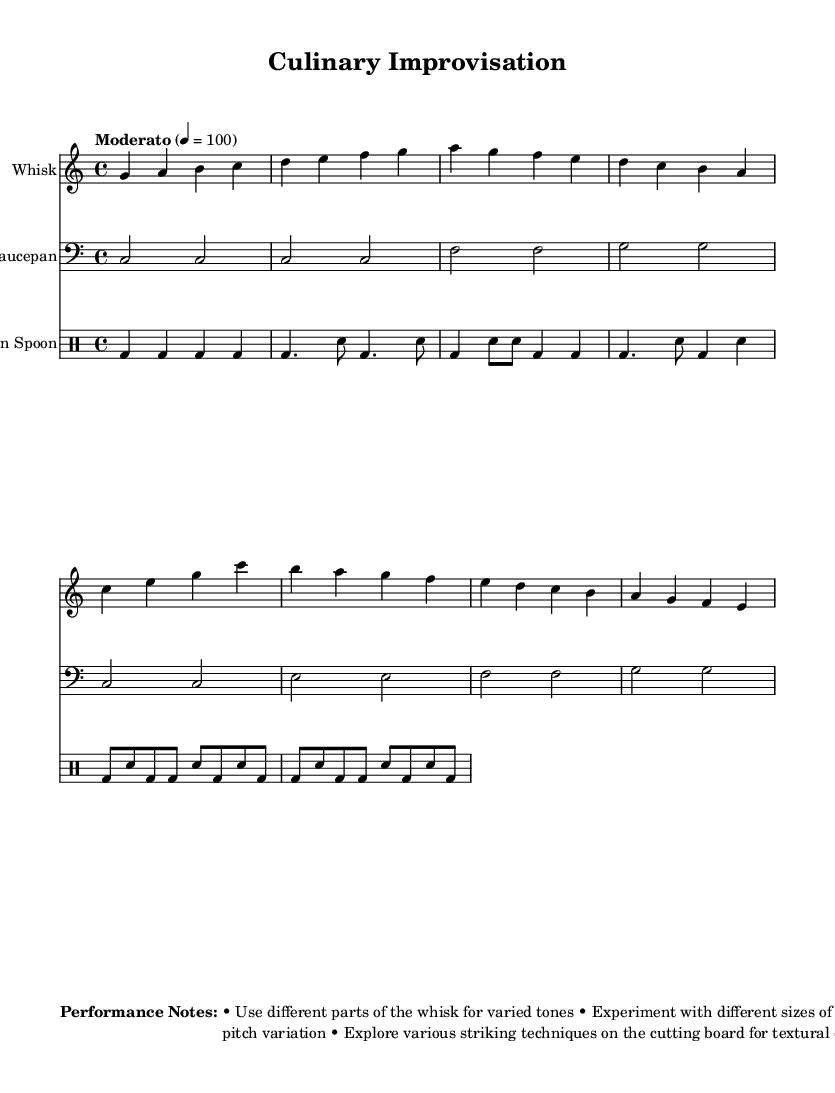What is the key signature of this music? The key signature is C major, which has no sharps or flats.
Answer: C major What is the time signature of this piece? The time signature is indicated as 4/4, meaning there are four beats in each measure.
Answer: 4/4 What is the tempo marking given in the music? The tempo marking is "Moderato," with a metronome indication of 100 beats per minute, suggesting a moderate pace.
Answer: Moderato How many measures are present in the 'Whisk' part's introduction? The 'Whisk' part's introduction consists of 4 measures, each containing the introductory notes.
Answer: 4 What type of instrument is used for the 'Wooden Spoon' part? The 'Wooden Spoon' part is written in drum mode, indicating it's intended for percussion instruments.
Answer: Percussion What is the primary rhythmic pattern used in the 'Wooden Spoon' part? The rhythmic pattern primarily alternates between bass drum and snare drum, creating a standard jazz rhythm.
Answer: Bass and snare What does the performance note suggest about using different parts of the whisk? The performance note suggests using different parts of the whisk to achieve varied tones, enhancing the experimental nature of the piece.
Answer: Varied tones 